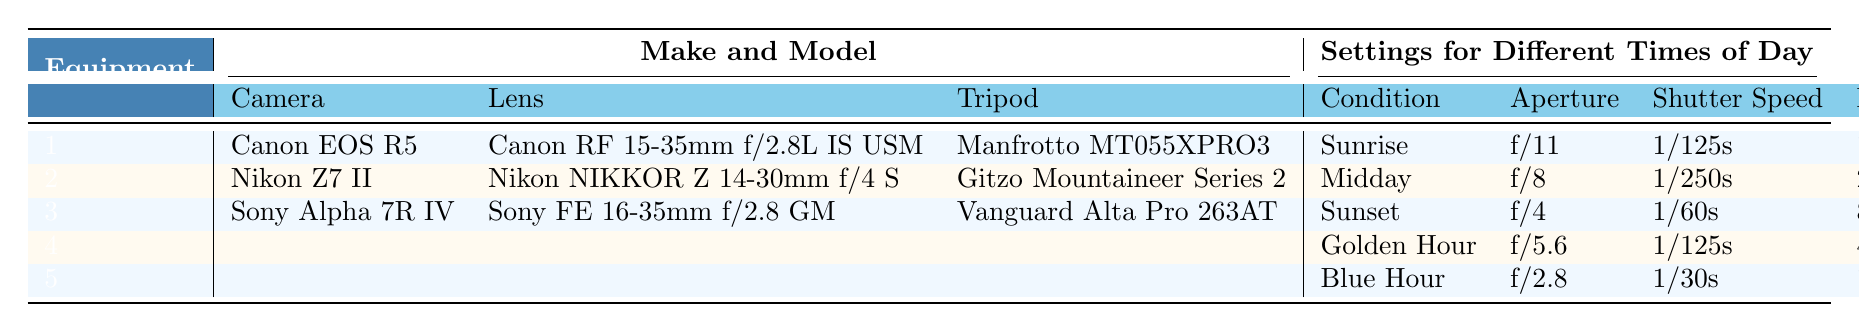What camera is used for Sunrise photography? The table shows that for the condition of Sunrise, the camera used is Canon EOS R5.
Answer: Canon EOS R5 What lens is paired with the Nikon Z7 II? According to the table, the lens paired with the Nikon Z7 II is Nikon NIKKOR Z 14-30mm f/4 S.
Answer: Nikon NIKKOR Z 14-30mm f/4 S What is the ISO setting for Sunset photography? For Sunset photography, the table specifies an ISO setting of 800.
Answer: 800 Which tripod is associated with the Sony Alpha 7R IV? The table indicates that the tripod associated with the Sony Alpha 7R IV is Vanguard Alta Pro 263AT.
Answer: Vanguard Alta Pro 263AT Is the aperture setting wider for Blue Hour than for Sunrise? The aperture for Blue Hour is f/2.8, whereas for Sunrise it is f/11. Since f/2.8 is wider than f/11, the statement is true.
Answer: Yes What is the average shutter speed for conditions that have both Golden Hour and Blue Hour settings? The shutter speed for Golden Hour is 1/125s and for Blue Hour is 1/30s. Convert these to fractions: 1/125 (0.008) and 1/30 (0.033). The average is (0.008 + 0.033) / 2 = 0.0205 or around 1/49s when calculated with a common denominator.
Answer: 1/49s Which lens has the fastest aperture setting, and what is its time of day condition? The lens with the fastest aperture setting is the Canon RF 15-35mm f/2.8L IS USM at f/2.8, but when keying on the available conditions, the fastest in the context is for Blue Hour.
Answer: Blue Hour What equipment is used for Golden Hour photography, and how does its ISO compare to that of Midday photography? For Golden Hour, the equipment is not specified for a camera, lens, or tripod in the table, but the ISO for Golden Hour is 400 compared to Midday, which is 200. Since 400 is greater than 200, the ISO for Golden Hour is higher than for Midday.
Answer: Higher What is the total number of different camera models listed in the equipment section of the table? The table lists three different camera models: Canon EOS R5, Nikon Z7 II, and Sony Alpha 7R IV. The total count is therefore 3.
Answer: 3 Which combination of equipment/settings should a photographer use if they want to take a picture at midday with the lowest ISO? The table shows that during Midday, the lowest ISO is 200 with the Nikon Z7 II camera, paired with the Nikon NIKKOR Z 14-30mm f/4 S lens and Gitzo Mountaineer Series 2 tripod. Thus, the required combination consists of these items.
Answer: Nikon Z7 II, Nikon NIKKOR Z 14-30mm f/4 S, Gitzo Mountaineer Series 2 